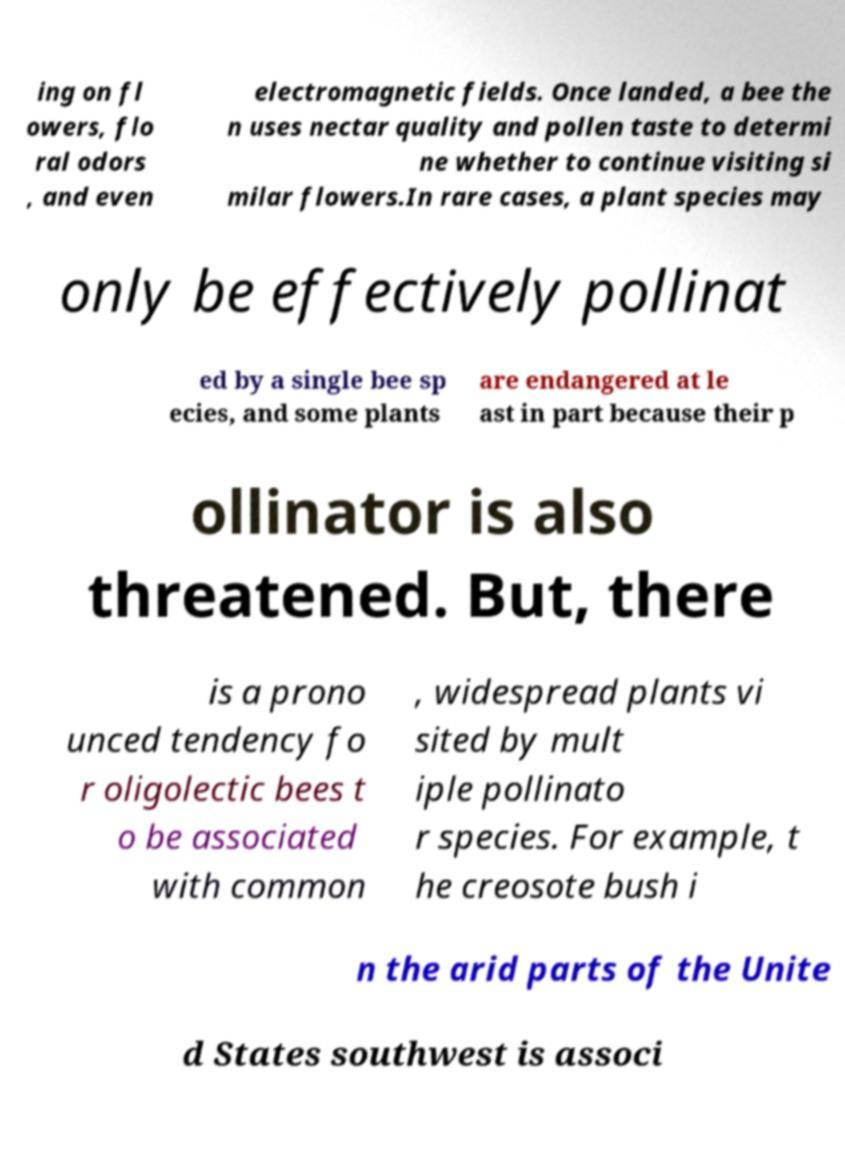Could you assist in decoding the text presented in this image and type it out clearly? ing on fl owers, flo ral odors , and even electromagnetic fields. Once landed, a bee the n uses nectar quality and pollen taste to determi ne whether to continue visiting si milar flowers.In rare cases, a plant species may only be effectively pollinat ed by a single bee sp ecies, and some plants are endangered at le ast in part because their p ollinator is also threatened. But, there is a prono unced tendency fo r oligolectic bees t o be associated with common , widespread plants vi sited by mult iple pollinato r species. For example, t he creosote bush i n the arid parts of the Unite d States southwest is associ 